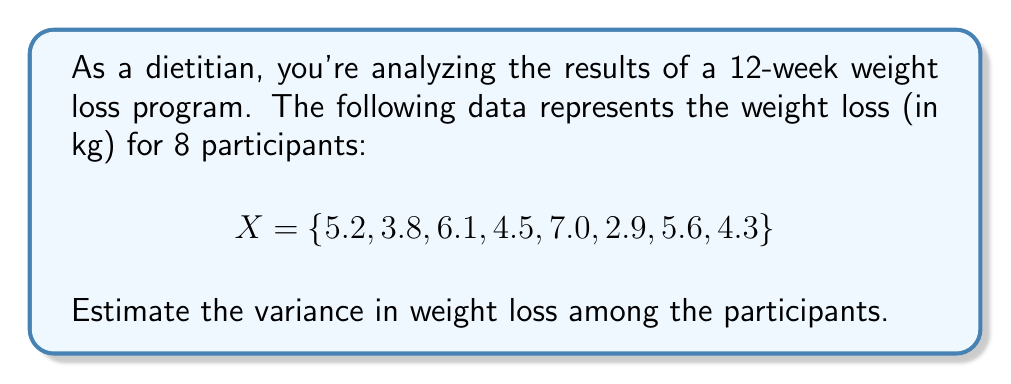Show me your answer to this math problem. To estimate the variance, we'll follow these steps:

1) First, calculate the mean weight loss:
   $$ \bar{X} = \frac{1}{n} \sum_{i=1}^n X_i = \frac{5.2 + 3.8 + 6.1 + 4.5 + 7.0 + 2.9 + 5.6 + 4.3}{8} = 4.925 \text{ kg} $$

2) Next, calculate the squared differences from the mean:
   $$ (5.2 - 4.925)^2 = 0.0756 $$
   $$ (3.8 - 4.925)^2 = 1.2656 $$
   $$ (6.1 - 4.925)^2 = 1.3806 $$
   $$ (4.5 - 4.925)^2 = 0.1806 $$
   $$ (7.0 - 4.925)^2 = 4.3056 $$
   $$ (2.9 - 4.925)^2 = 4.1006 $$
   $$ (5.6 - 4.925)^2 = 0.4556 $$
   $$ (4.3 - 4.925)^2 = 0.3906 $$

3) Sum these squared differences:
   $$ \sum_{i=1}^n (X_i - \bar{X})^2 = 12.1548 $$

4) Divide by $(n-1) = 7$ to get the sample variance:
   $$ s^2 = \frac{1}{n-1} \sum_{i=1}^n (X_i - \bar{X})^2 = \frac{12.1548}{7} = 1.7364 $$

Therefore, the estimated variance in weight loss is 1.7364 kg².
Answer: 1.7364 kg² 